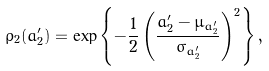<formula> <loc_0><loc_0><loc_500><loc_500>\rho _ { 2 } ( a _ { 2 } ^ { \prime } ) = \exp \left \{ - \frac { 1 } { 2 } \left ( \frac { a _ { 2 } ^ { \prime } - \mu _ { a _ { 2 } ^ { \prime } } } { \sigma _ { a _ { 2 } ^ { \prime } } } \right ) ^ { 2 } \right \} ,</formula> 